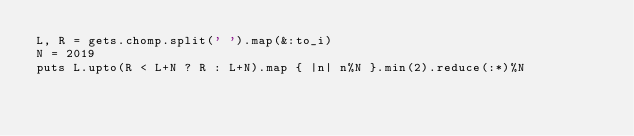Convert code to text. <code><loc_0><loc_0><loc_500><loc_500><_Ruby_>L, R = gets.chomp.split(' ').map(&:to_i)
N = 2019
puts L.upto(R < L+N ? R : L+N).map { |n| n%N }.min(2).reduce(:*)%N</code> 